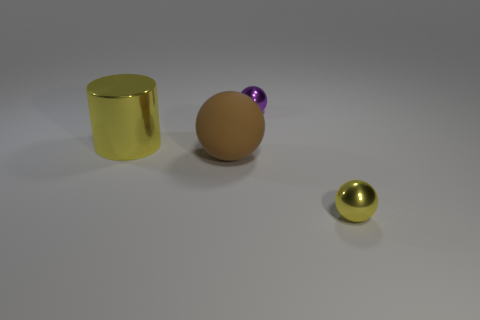What number of purple shiny objects have the same shape as the large yellow metallic object?
Make the answer very short. 0. What is the size of the yellow ball that is the same material as the tiny purple ball?
Keep it short and to the point. Small. What color is the small metallic ball in front of the small ball behind the rubber sphere?
Provide a succinct answer. Yellow. There is a brown thing; is it the same shape as the metal thing on the right side of the purple object?
Offer a terse response. Yes. How many other brown balls have the same size as the brown rubber ball?
Provide a short and direct response. 0. What is the material of the small purple thing that is the same shape as the large brown thing?
Ensure brevity in your answer.  Metal. Do the tiny object in front of the small purple thing and the shiny thing left of the small purple metal object have the same color?
Offer a very short reply. Yes. What is the shape of the big yellow thing to the left of the tiny yellow metallic object?
Offer a terse response. Cylinder. The big metal cylinder is what color?
Your answer should be very brief. Yellow. There is a large yellow object that is the same material as the purple object; what is its shape?
Your response must be concise. Cylinder. 